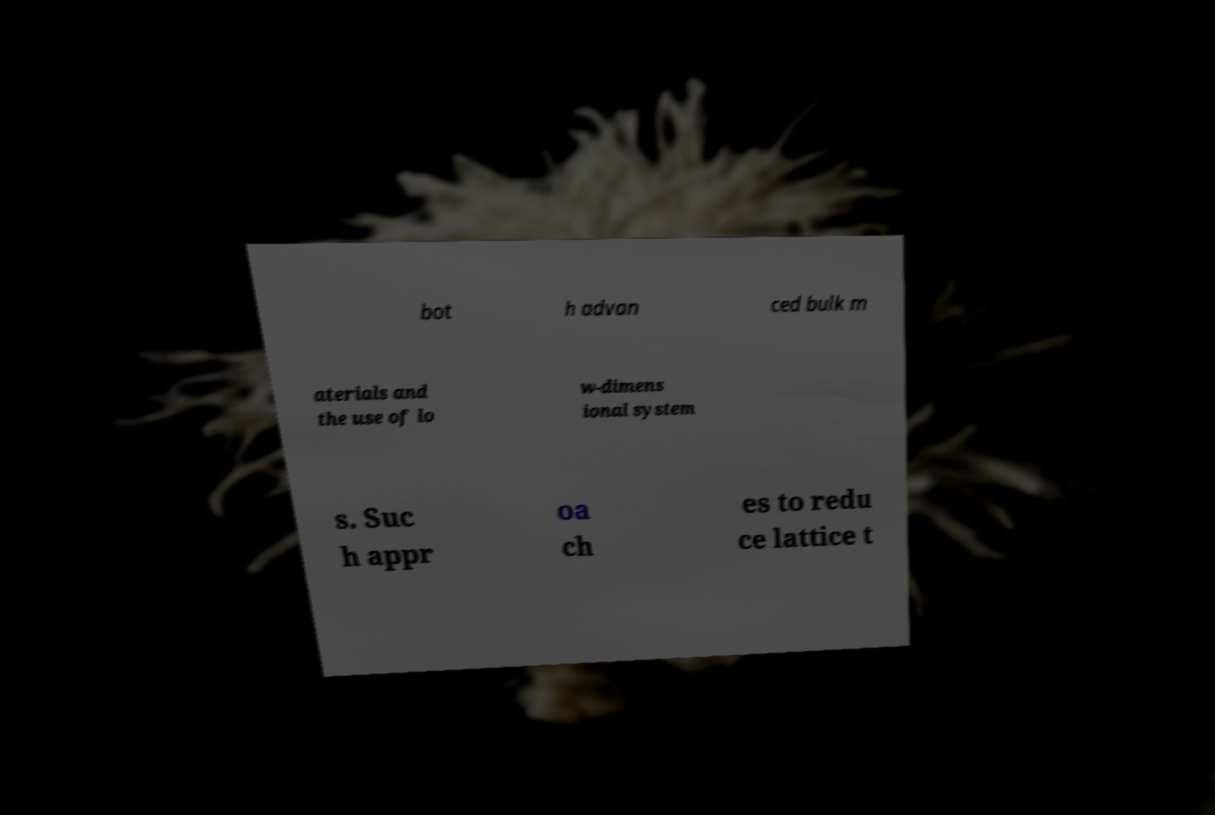Please read and relay the text visible in this image. What does it say? bot h advan ced bulk m aterials and the use of lo w-dimens ional system s. Suc h appr oa ch es to redu ce lattice t 